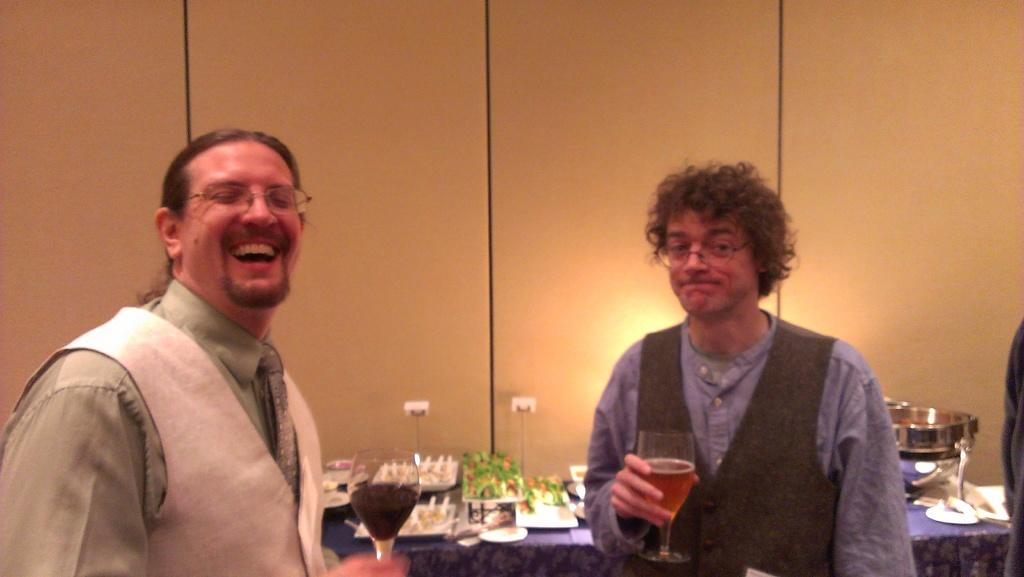How many people are in the image? There are two people standing in the image. What are the people holding in their hands? The people are holding glasses. What can be seen in the background of the image? There is a table and a wall in the background of the image. What is placed on the table? Objects are placed on the table. What type of garden can be seen in the image? There is no garden present in the image. What is the relationship between the two people in the image? The provided facts do not give any information about the relationship between the two people. 